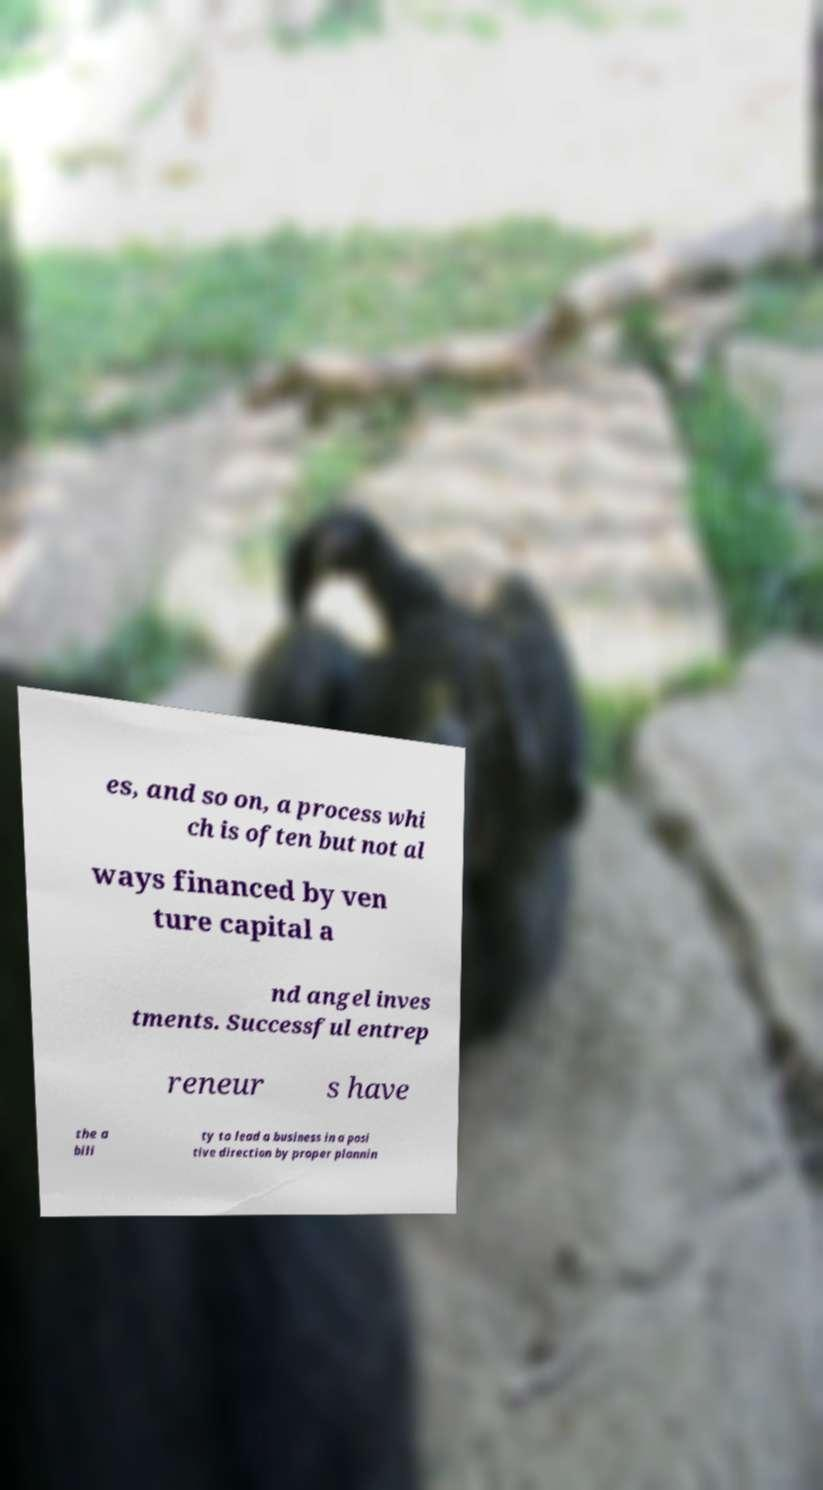I need the written content from this picture converted into text. Can you do that? es, and so on, a process whi ch is often but not al ways financed by ven ture capital a nd angel inves tments. Successful entrep reneur s have the a bili ty to lead a business in a posi tive direction by proper plannin 